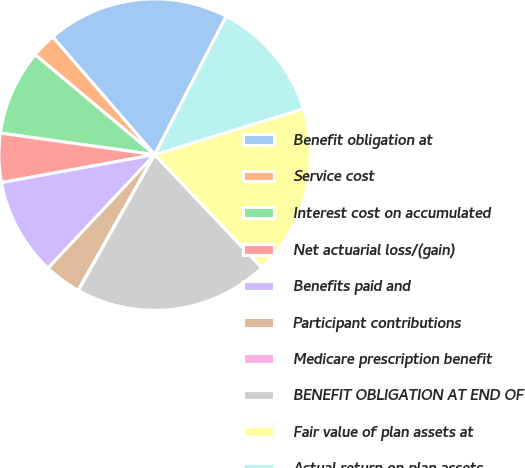<chart> <loc_0><loc_0><loc_500><loc_500><pie_chart><fcel>Benefit obligation at<fcel>Service cost<fcel>Interest cost on accumulated<fcel>Net actuarial loss/(gain)<fcel>Benefits paid and<fcel>Participant contributions<fcel>Medicare prescription benefit<fcel>BENEFIT OBLIGATION AT END OF<fcel>Fair value of plan assets at<fcel>Actual return on plan assets<nl><fcel>18.95%<fcel>2.56%<fcel>8.87%<fcel>5.08%<fcel>10.13%<fcel>3.82%<fcel>0.04%<fcel>20.21%<fcel>17.69%<fcel>12.65%<nl></chart> 